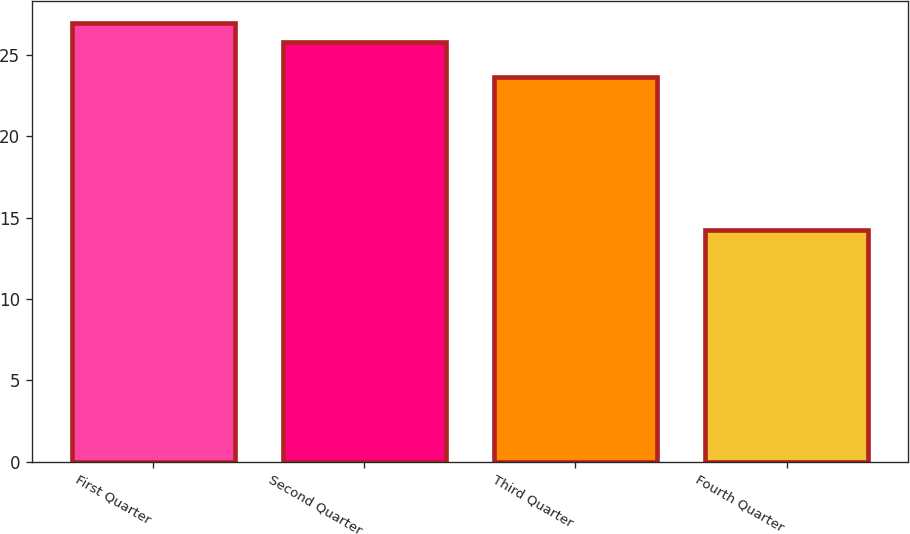Convert chart. <chart><loc_0><loc_0><loc_500><loc_500><bar_chart><fcel>First Quarter<fcel>Second Quarter<fcel>Third Quarter<fcel>Fourth Quarter<nl><fcel>26.97<fcel>25.79<fcel>23.63<fcel>14.26<nl></chart> 